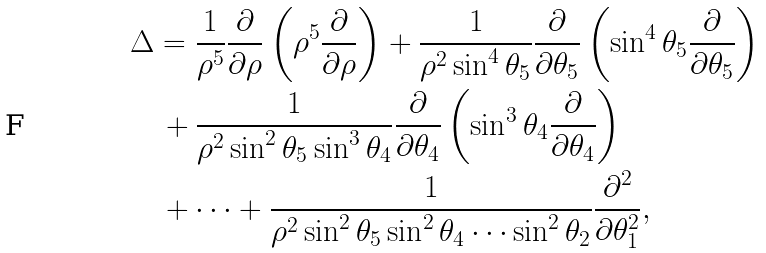Convert formula to latex. <formula><loc_0><loc_0><loc_500><loc_500>& \Delta = \frac { 1 } { \rho ^ { 5 } } \frac { \partial } { \partial \rho } \left ( \rho ^ { 5 } \frac { \partial } { \partial \rho } \right ) + \frac { 1 } { \rho ^ { 2 } \sin ^ { 4 } \theta _ { 5 } } \frac { \partial } { \partial \theta _ { 5 } } \left ( \sin ^ { 4 } \theta _ { 5 } \frac { \partial } { \partial \theta _ { 5 } } \right ) \\ & \quad + \frac { 1 } { \rho ^ { 2 } \sin ^ { 2 } \theta _ { 5 } \sin ^ { 3 } \theta _ { 4 } } \frac { \partial } { \partial \theta _ { 4 } } \left ( \sin ^ { 3 } \theta _ { 4 } \frac { \partial } { \partial \theta _ { 4 } } \right ) \\ & \quad + \cdots + \frac { 1 } { \rho ^ { 2 } \sin ^ { 2 } \theta _ { 5 } \sin ^ { 2 } \theta _ { 4 } \cdots \sin ^ { 2 } \theta _ { 2 } } \frac { \partial ^ { 2 } } { \partial \theta _ { 1 } ^ { 2 } } ,</formula> 